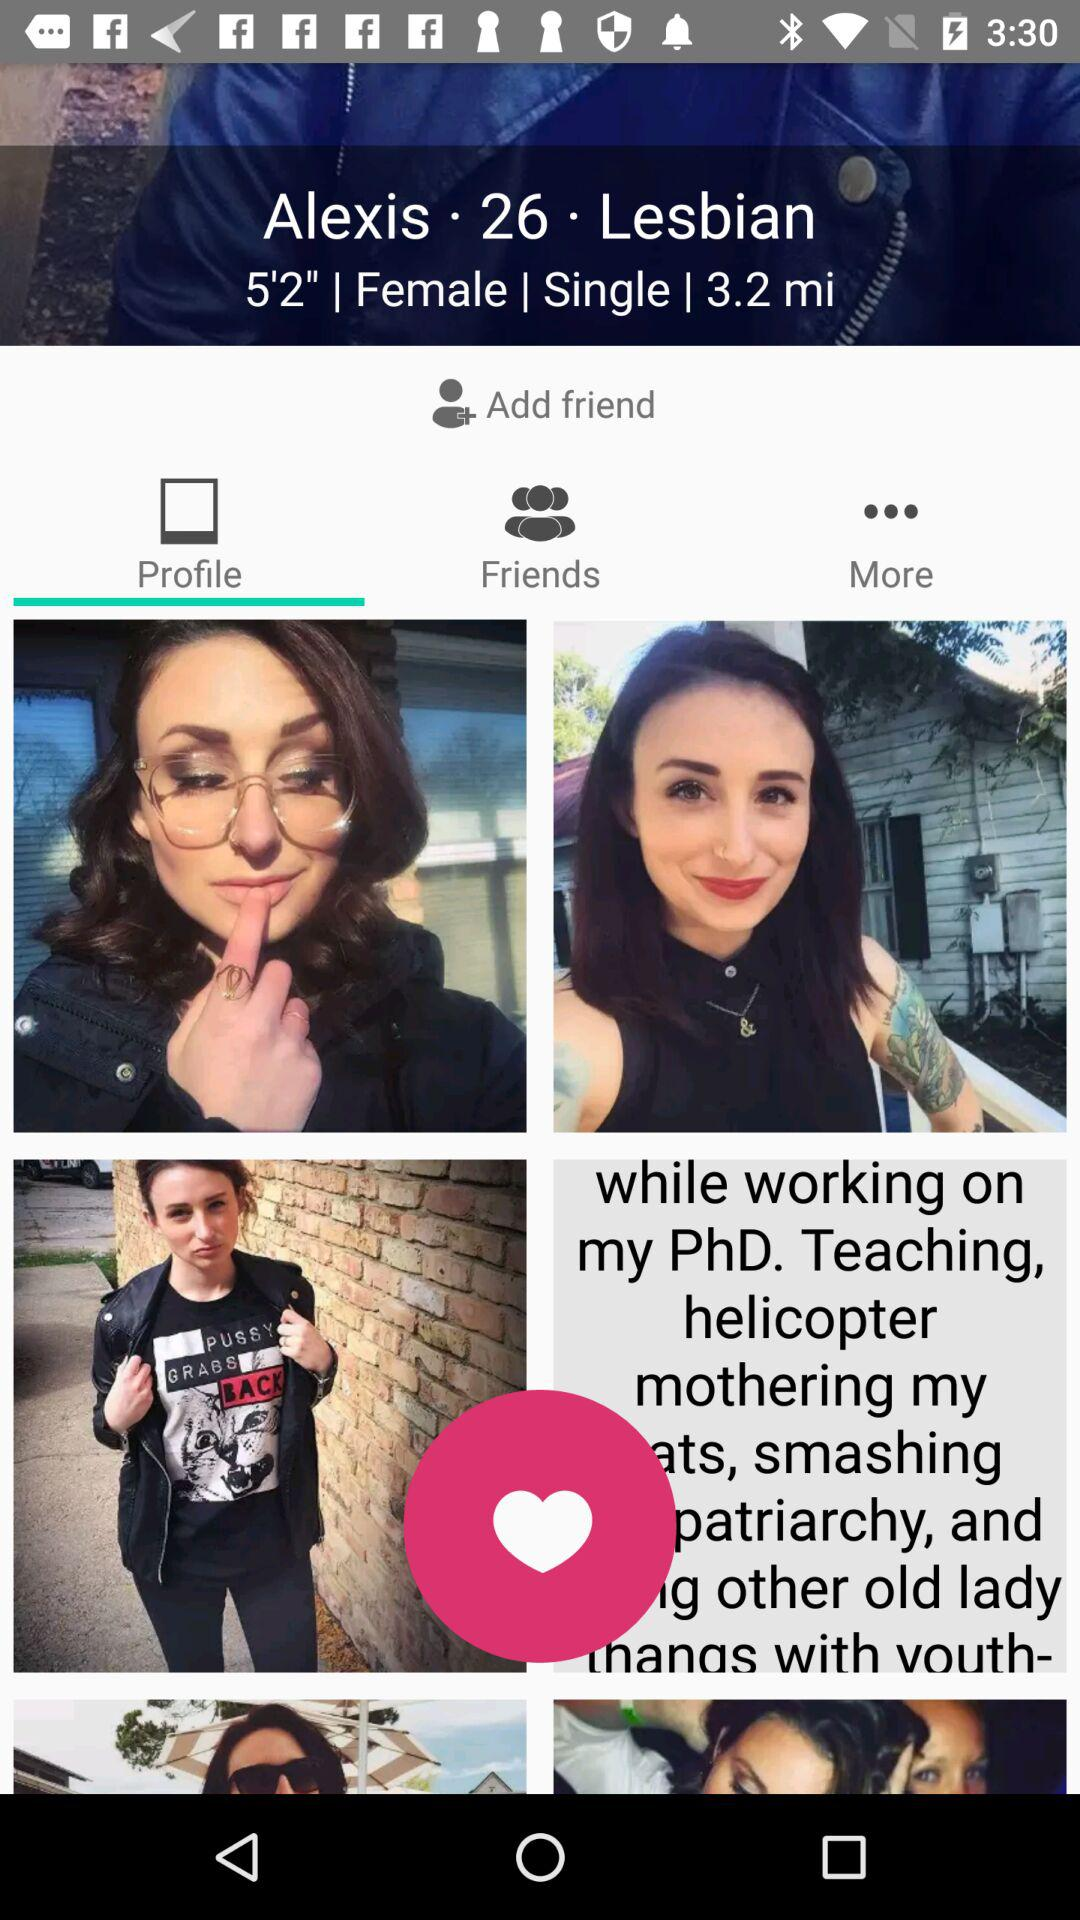What is Alexis' marital status? Alexis' marital status is single. 